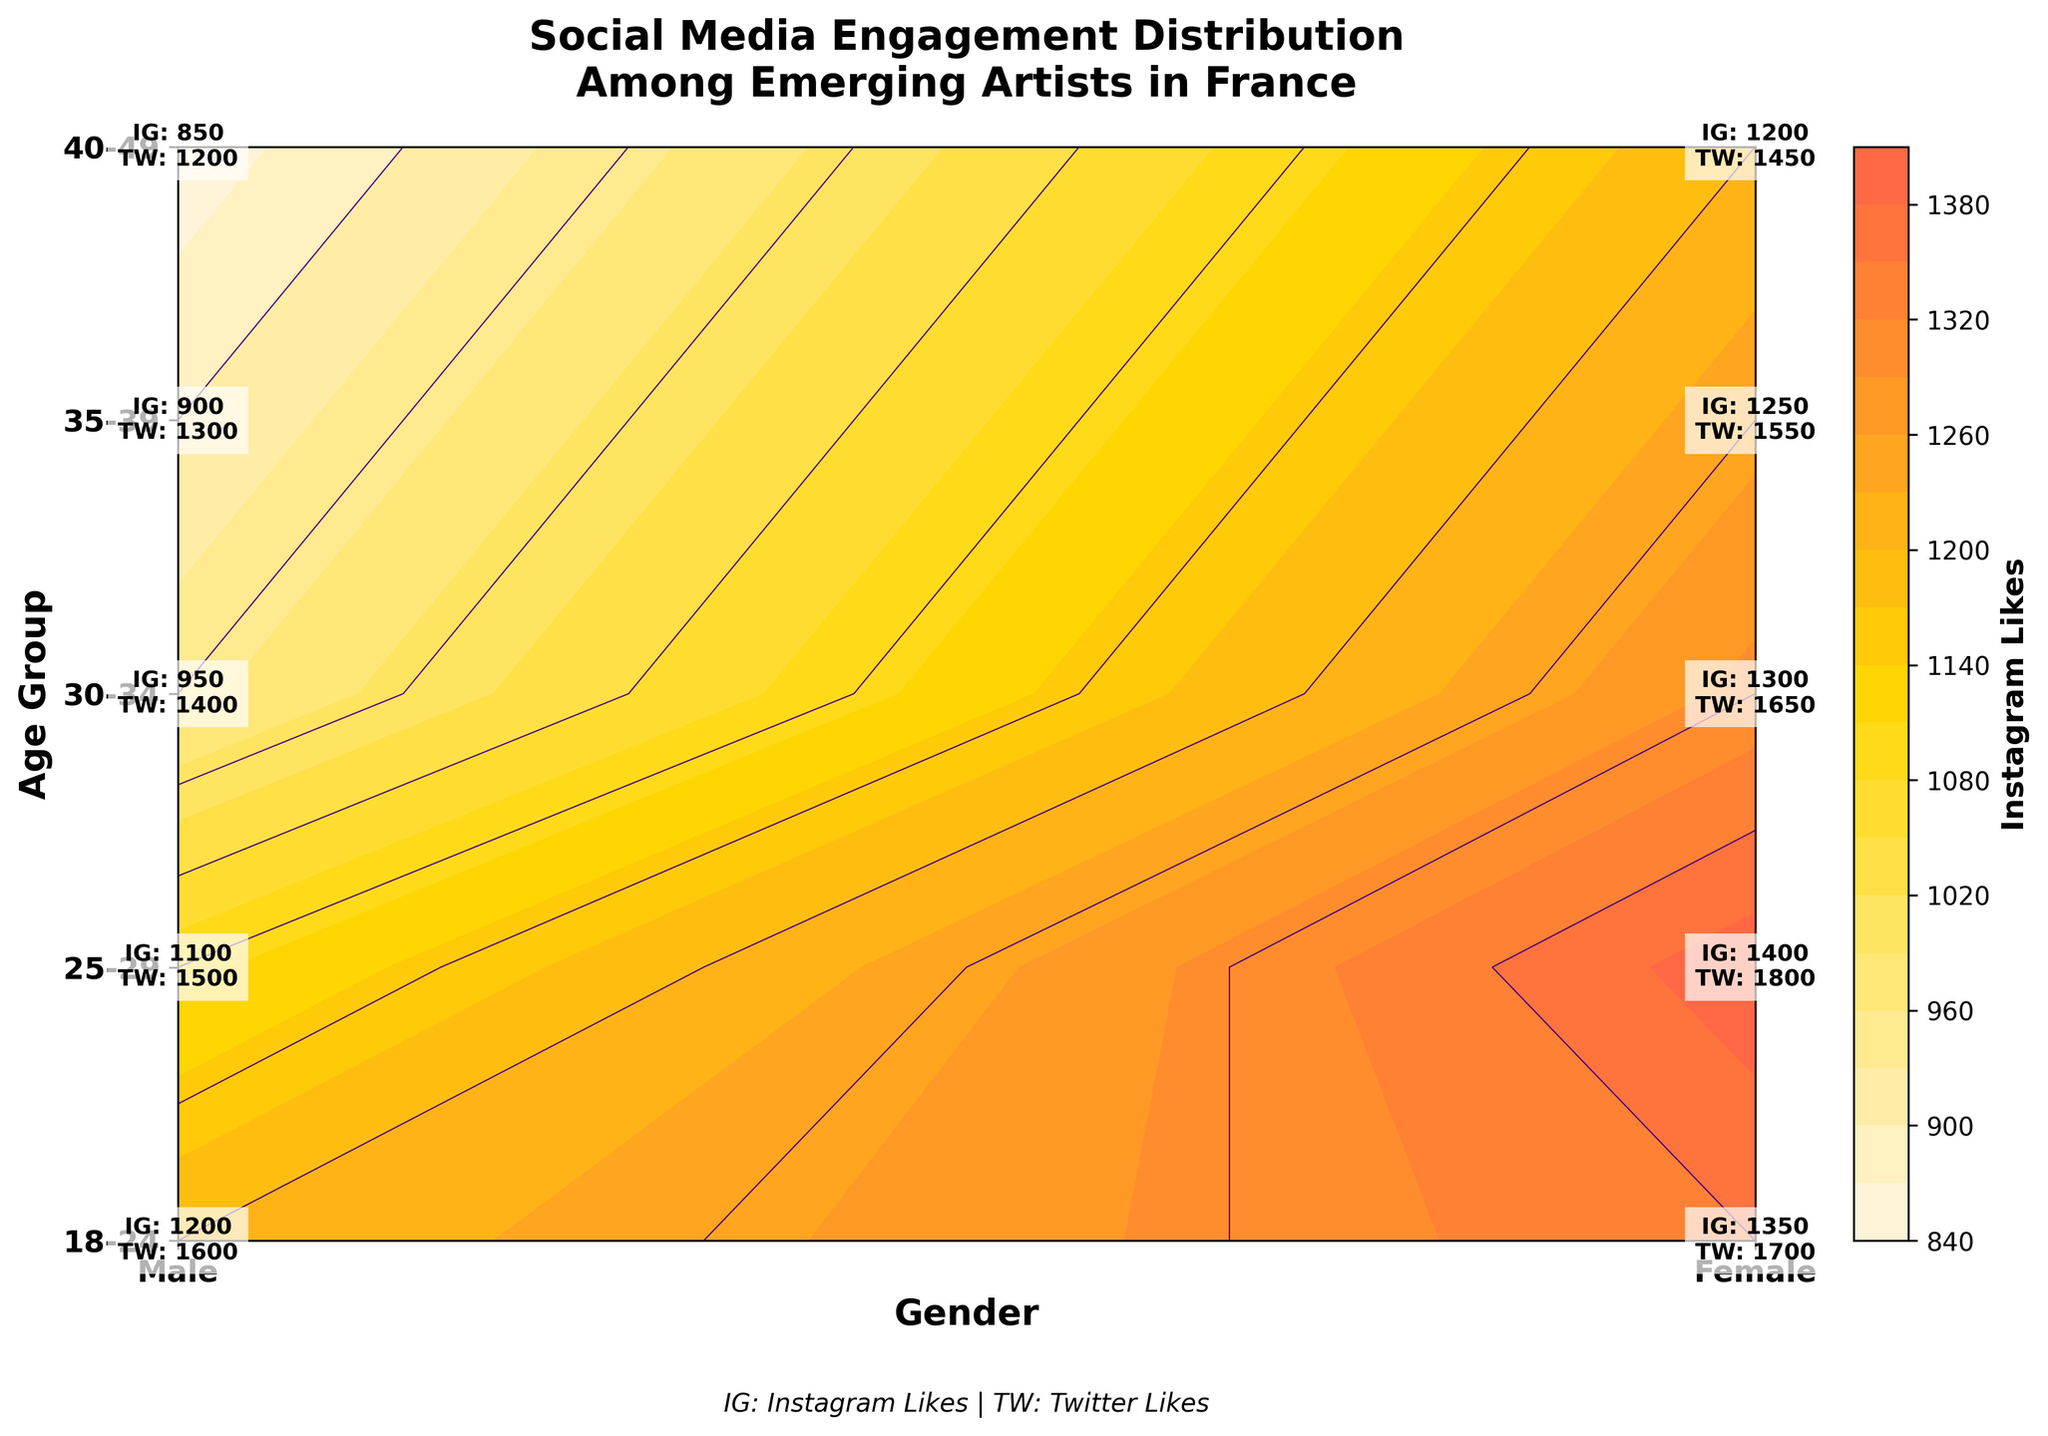What's the title of the figure? The title of the figure is displayed at the top of the plot as "Social Media Engagement Distribution\nAmong Emerging Artists in France".
Answer: Social Media Engagement Distribution Among Emerging Artists in France What does the color bar represent? The color bar represents the number of Instagram Likes, as indicated by the label beside the color bar.
Answer: Instagram Likes Which age-gender group has the highest Instagram Likes? In the figure, the highest Instagram Likes value appears in the "25-29" Female group with a label indicating 1400 likes.
Answer: 25-29 Female How many age groups are shown in the figure? The y-axis labels "18-24", "25-29", "30-34", "35-39", and "40-49" represent the five different age groups shown in the figure.
Answer: 5 Compare the Instagram Likes of 18-24 Male and Female groups. Which is higher? The labels for "18-24" show the Male group has 1200 likes and the Female group has 1350 likes, making the Female group's Instagram Likes higher.
Answer: Female What are the Twitter Likes for the "30-34" age group for both genders? From the labels, the Twitter Likes for "30-34" Male is 1400 and for "30-34" Female is 1650.
Answer: Male: 1400, Female: 1650 Which gender generally has higher total Instagram Likes across all age groups? By visually summing the Instagram Likes from all age groups, it is visible that Female generally has higher total Instagram Likes when compared to Male.
Answer: Female For the "40-49" age group, what is the difference in Instagram Likes between Male and Female? The "40-49" Male group has 850 likes and the Female group has 1200 likes. The difference is 1200 - 850 = 350.
Answer: 350 Explain the purpose of the custom colormap in the figure. The custom colormap uses different shades to depict varying levels of Instagram Likes, helping to distinguish low, medium, and high engagement visually.
Answer: To distinguish levels of Instagram Likes What additional information, besides Instagram Likes, is provided within each contour label? Each contour label also provides Twitter Likes information for the corresponding age-gender group by indicating it as "TW: {value}".
Answer: Twitter Likes 